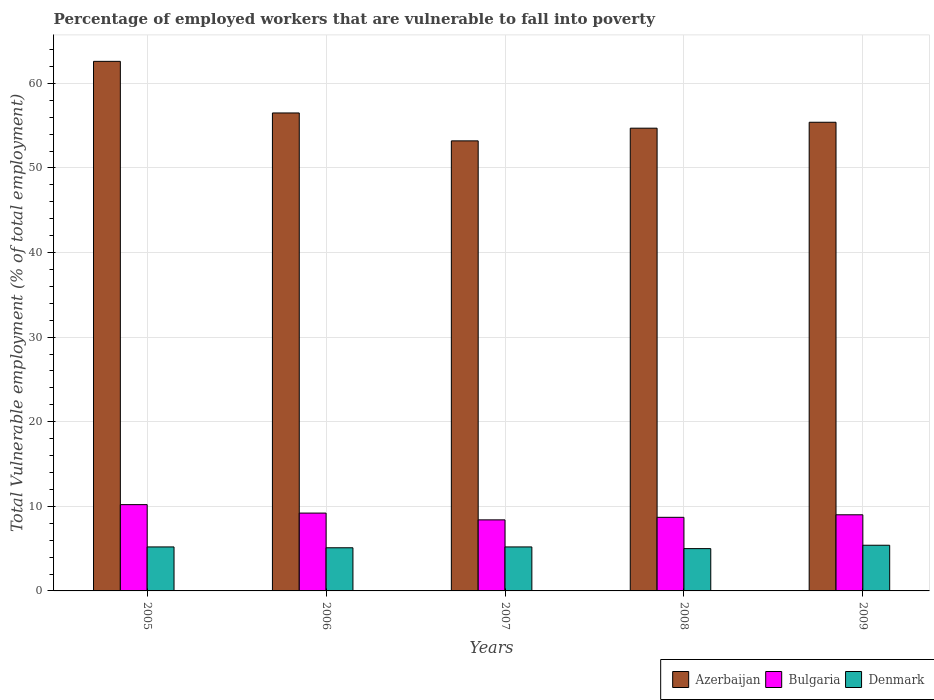How many groups of bars are there?
Offer a terse response. 5. Are the number of bars per tick equal to the number of legend labels?
Your answer should be very brief. Yes. Are the number of bars on each tick of the X-axis equal?
Give a very brief answer. Yes. How many bars are there on the 5th tick from the left?
Provide a short and direct response. 3. How many bars are there on the 1st tick from the right?
Your answer should be very brief. 3. What is the percentage of employed workers who are vulnerable to fall into poverty in Bulgaria in 2008?
Your answer should be very brief. 8.7. Across all years, what is the maximum percentage of employed workers who are vulnerable to fall into poverty in Bulgaria?
Make the answer very short. 10.2. Across all years, what is the minimum percentage of employed workers who are vulnerable to fall into poverty in Bulgaria?
Make the answer very short. 8.4. In which year was the percentage of employed workers who are vulnerable to fall into poverty in Bulgaria maximum?
Make the answer very short. 2005. In which year was the percentage of employed workers who are vulnerable to fall into poverty in Bulgaria minimum?
Give a very brief answer. 2007. What is the total percentage of employed workers who are vulnerable to fall into poverty in Denmark in the graph?
Provide a short and direct response. 25.9. What is the difference between the percentage of employed workers who are vulnerable to fall into poverty in Denmark in 2008 and that in 2009?
Make the answer very short. -0.4. What is the difference between the percentage of employed workers who are vulnerable to fall into poverty in Bulgaria in 2008 and the percentage of employed workers who are vulnerable to fall into poverty in Denmark in 2007?
Your response must be concise. 3.5. What is the average percentage of employed workers who are vulnerable to fall into poverty in Bulgaria per year?
Ensure brevity in your answer.  9.1. In the year 2009, what is the difference between the percentage of employed workers who are vulnerable to fall into poverty in Bulgaria and percentage of employed workers who are vulnerable to fall into poverty in Denmark?
Ensure brevity in your answer.  3.6. What is the ratio of the percentage of employed workers who are vulnerable to fall into poverty in Azerbaijan in 2005 to that in 2007?
Your answer should be compact. 1.18. What is the difference between the highest and the second highest percentage of employed workers who are vulnerable to fall into poverty in Bulgaria?
Provide a short and direct response. 1. What is the difference between the highest and the lowest percentage of employed workers who are vulnerable to fall into poverty in Azerbaijan?
Offer a very short reply. 9.4. In how many years, is the percentage of employed workers who are vulnerable to fall into poverty in Azerbaijan greater than the average percentage of employed workers who are vulnerable to fall into poverty in Azerbaijan taken over all years?
Your answer should be compact. 2. Is the sum of the percentage of employed workers who are vulnerable to fall into poverty in Azerbaijan in 2006 and 2009 greater than the maximum percentage of employed workers who are vulnerable to fall into poverty in Bulgaria across all years?
Keep it short and to the point. Yes. What does the 2nd bar from the left in 2008 represents?
Keep it short and to the point. Bulgaria. What does the 2nd bar from the right in 2007 represents?
Give a very brief answer. Bulgaria. Is it the case that in every year, the sum of the percentage of employed workers who are vulnerable to fall into poverty in Bulgaria and percentage of employed workers who are vulnerable to fall into poverty in Azerbaijan is greater than the percentage of employed workers who are vulnerable to fall into poverty in Denmark?
Your answer should be compact. Yes. How many bars are there?
Make the answer very short. 15. How many years are there in the graph?
Provide a succinct answer. 5. Are the values on the major ticks of Y-axis written in scientific E-notation?
Offer a very short reply. No. Does the graph contain any zero values?
Ensure brevity in your answer.  No. What is the title of the graph?
Give a very brief answer. Percentage of employed workers that are vulnerable to fall into poverty. What is the label or title of the Y-axis?
Make the answer very short. Total Vulnerable employment (% of total employment). What is the Total Vulnerable employment (% of total employment) of Azerbaijan in 2005?
Give a very brief answer. 62.6. What is the Total Vulnerable employment (% of total employment) in Bulgaria in 2005?
Your answer should be compact. 10.2. What is the Total Vulnerable employment (% of total employment) of Denmark in 2005?
Your answer should be very brief. 5.2. What is the Total Vulnerable employment (% of total employment) in Azerbaijan in 2006?
Provide a short and direct response. 56.5. What is the Total Vulnerable employment (% of total employment) of Bulgaria in 2006?
Offer a terse response. 9.2. What is the Total Vulnerable employment (% of total employment) in Denmark in 2006?
Provide a short and direct response. 5.1. What is the Total Vulnerable employment (% of total employment) of Azerbaijan in 2007?
Your answer should be compact. 53.2. What is the Total Vulnerable employment (% of total employment) of Bulgaria in 2007?
Make the answer very short. 8.4. What is the Total Vulnerable employment (% of total employment) in Denmark in 2007?
Ensure brevity in your answer.  5.2. What is the Total Vulnerable employment (% of total employment) of Azerbaijan in 2008?
Your answer should be compact. 54.7. What is the Total Vulnerable employment (% of total employment) of Bulgaria in 2008?
Ensure brevity in your answer.  8.7. What is the Total Vulnerable employment (% of total employment) in Azerbaijan in 2009?
Your answer should be very brief. 55.4. What is the Total Vulnerable employment (% of total employment) in Bulgaria in 2009?
Your response must be concise. 9. What is the Total Vulnerable employment (% of total employment) of Denmark in 2009?
Keep it short and to the point. 5.4. Across all years, what is the maximum Total Vulnerable employment (% of total employment) of Azerbaijan?
Your answer should be very brief. 62.6. Across all years, what is the maximum Total Vulnerable employment (% of total employment) in Bulgaria?
Make the answer very short. 10.2. Across all years, what is the maximum Total Vulnerable employment (% of total employment) in Denmark?
Your response must be concise. 5.4. Across all years, what is the minimum Total Vulnerable employment (% of total employment) of Azerbaijan?
Provide a succinct answer. 53.2. Across all years, what is the minimum Total Vulnerable employment (% of total employment) in Bulgaria?
Your answer should be very brief. 8.4. Across all years, what is the minimum Total Vulnerable employment (% of total employment) in Denmark?
Give a very brief answer. 5. What is the total Total Vulnerable employment (% of total employment) of Azerbaijan in the graph?
Your answer should be compact. 282.4. What is the total Total Vulnerable employment (% of total employment) in Bulgaria in the graph?
Ensure brevity in your answer.  45.5. What is the total Total Vulnerable employment (% of total employment) of Denmark in the graph?
Your response must be concise. 25.9. What is the difference between the Total Vulnerable employment (% of total employment) of Bulgaria in 2005 and that in 2006?
Provide a succinct answer. 1. What is the difference between the Total Vulnerable employment (% of total employment) in Azerbaijan in 2005 and that in 2007?
Offer a terse response. 9.4. What is the difference between the Total Vulnerable employment (% of total employment) of Denmark in 2005 and that in 2007?
Make the answer very short. 0. What is the difference between the Total Vulnerable employment (% of total employment) of Azerbaijan in 2005 and that in 2008?
Your answer should be compact. 7.9. What is the difference between the Total Vulnerable employment (% of total employment) of Bulgaria in 2005 and that in 2008?
Provide a succinct answer. 1.5. What is the difference between the Total Vulnerable employment (% of total employment) in Denmark in 2005 and that in 2008?
Offer a very short reply. 0.2. What is the difference between the Total Vulnerable employment (% of total employment) in Azerbaijan in 2005 and that in 2009?
Keep it short and to the point. 7.2. What is the difference between the Total Vulnerable employment (% of total employment) in Azerbaijan in 2006 and that in 2007?
Your answer should be very brief. 3.3. What is the difference between the Total Vulnerable employment (% of total employment) in Bulgaria in 2006 and that in 2007?
Make the answer very short. 0.8. What is the difference between the Total Vulnerable employment (% of total employment) of Azerbaijan in 2006 and that in 2008?
Ensure brevity in your answer.  1.8. What is the difference between the Total Vulnerable employment (% of total employment) of Bulgaria in 2006 and that in 2008?
Make the answer very short. 0.5. What is the difference between the Total Vulnerable employment (% of total employment) of Azerbaijan in 2006 and that in 2009?
Your response must be concise. 1.1. What is the difference between the Total Vulnerable employment (% of total employment) of Azerbaijan in 2007 and that in 2009?
Keep it short and to the point. -2.2. What is the difference between the Total Vulnerable employment (% of total employment) in Denmark in 2007 and that in 2009?
Your response must be concise. -0.2. What is the difference between the Total Vulnerable employment (% of total employment) of Azerbaijan in 2008 and that in 2009?
Your answer should be very brief. -0.7. What is the difference between the Total Vulnerable employment (% of total employment) of Azerbaijan in 2005 and the Total Vulnerable employment (% of total employment) of Bulgaria in 2006?
Keep it short and to the point. 53.4. What is the difference between the Total Vulnerable employment (% of total employment) of Azerbaijan in 2005 and the Total Vulnerable employment (% of total employment) of Denmark in 2006?
Provide a short and direct response. 57.5. What is the difference between the Total Vulnerable employment (% of total employment) of Azerbaijan in 2005 and the Total Vulnerable employment (% of total employment) of Bulgaria in 2007?
Offer a very short reply. 54.2. What is the difference between the Total Vulnerable employment (% of total employment) in Azerbaijan in 2005 and the Total Vulnerable employment (% of total employment) in Denmark in 2007?
Your response must be concise. 57.4. What is the difference between the Total Vulnerable employment (% of total employment) in Bulgaria in 2005 and the Total Vulnerable employment (% of total employment) in Denmark in 2007?
Offer a terse response. 5. What is the difference between the Total Vulnerable employment (% of total employment) in Azerbaijan in 2005 and the Total Vulnerable employment (% of total employment) in Bulgaria in 2008?
Make the answer very short. 53.9. What is the difference between the Total Vulnerable employment (% of total employment) of Azerbaijan in 2005 and the Total Vulnerable employment (% of total employment) of Denmark in 2008?
Make the answer very short. 57.6. What is the difference between the Total Vulnerable employment (% of total employment) of Azerbaijan in 2005 and the Total Vulnerable employment (% of total employment) of Bulgaria in 2009?
Offer a terse response. 53.6. What is the difference between the Total Vulnerable employment (% of total employment) in Azerbaijan in 2005 and the Total Vulnerable employment (% of total employment) in Denmark in 2009?
Offer a very short reply. 57.2. What is the difference between the Total Vulnerable employment (% of total employment) in Azerbaijan in 2006 and the Total Vulnerable employment (% of total employment) in Bulgaria in 2007?
Offer a terse response. 48.1. What is the difference between the Total Vulnerable employment (% of total employment) of Azerbaijan in 2006 and the Total Vulnerable employment (% of total employment) of Denmark in 2007?
Make the answer very short. 51.3. What is the difference between the Total Vulnerable employment (% of total employment) in Azerbaijan in 2006 and the Total Vulnerable employment (% of total employment) in Bulgaria in 2008?
Your answer should be very brief. 47.8. What is the difference between the Total Vulnerable employment (% of total employment) in Azerbaijan in 2006 and the Total Vulnerable employment (% of total employment) in Denmark in 2008?
Provide a succinct answer. 51.5. What is the difference between the Total Vulnerable employment (% of total employment) in Azerbaijan in 2006 and the Total Vulnerable employment (% of total employment) in Bulgaria in 2009?
Your answer should be very brief. 47.5. What is the difference between the Total Vulnerable employment (% of total employment) in Azerbaijan in 2006 and the Total Vulnerable employment (% of total employment) in Denmark in 2009?
Provide a short and direct response. 51.1. What is the difference between the Total Vulnerable employment (% of total employment) of Azerbaijan in 2007 and the Total Vulnerable employment (% of total employment) of Bulgaria in 2008?
Your answer should be very brief. 44.5. What is the difference between the Total Vulnerable employment (% of total employment) in Azerbaijan in 2007 and the Total Vulnerable employment (% of total employment) in Denmark in 2008?
Offer a very short reply. 48.2. What is the difference between the Total Vulnerable employment (% of total employment) in Bulgaria in 2007 and the Total Vulnerable employment (% of total employment) in Denmark in 2008?
Your answer should be very brief. 3.4. What is the difference between the Total Vulnerable employment (% of total employment) of Azerbaijan in 2007 and the Total Vulnerable employment (% of total employment) of Bulgaria in 2009?
Provide a succinct answer. 44.2. What is the difference between the Total Vulnerable employment (% of total employment) in Azerbaijan in 2007 and the Total Vulnerable employment (% of total employment) in Denmark in 2009?
Provide a succinct answer. 47.8. What is the difference between the Total Vulnerable employment (% of total employment) of Azerbaijan in 2008 and the Total Vulnerable employment (% of total employment) of Bulgaria in 2009?
Provide a short and direct response. 45.7. What is the difference between the Total Vulnerable employment (% of total employment) in Azerbaijan in 2008 and the Total Vulnerable employment (% of total employment) in Denmark in 2009?
Offer a terse response. 49.3. What is the difference between the Total Vulnerable employment (% of total employment) in Bulgaria in 2008 and the Total Vulnerable employment (% of total employment) in Denmark in 2009?
Ensure brevity in your answer.  3.3. What is the average Total Vulnerable employment (% of total employment) of Azerbaijan per year?
Your response must be concise. 56.48. What is the average Total Vulnerable employment (% of total employment) in Bulgaria per year?
Make the answer very short. 9.1. What is the average Total Vulnerable employment (% of total employment) of Denmark per year?
Provide a short and direct response. 5.18. In the year 2005, what is the difference between the Total Vulnerable employment (% of total employment) of Azerbaijan and Total Vulnerable employment (% of total employment) of Bulgaria?
Provide a succinct answer. 52.4. In the year 2005, what is the difference between the Total Vulnerable employment (% of total employment) in Azerbaijan and Total Vulnerable employment (% of total employment) in Denmark?
Provide a short and direct response. 57.4. In the year 2006, what is the difference between the Total Vulnerable employment (% of total employment) in Azerbaijan and Total Vulnerable employment (% of total employment) in Bulgaria?
Offer a very short reply. 47.3. In the year 2006, what is the difference between the Total Vulnerable employment (% of total employment) of Azerbaijan and Total Vulnerable employment (% of total employment) of Denmark?
Offer a very short reply. 51.4. In the year 2006, what is the difference between the Total Vulnerable employment (% of total employment) in Bulgaria and Total Vulnerable employment (% of total employment) in Denmark?
Provide a succinct answer. 4.1. In the year 2007, what is the difference between the Total Vulnerable employment (% of total employment) of Azerbaijan and Total Vulnerable employment (% of total employment) of Bulgaria?
Your answer should be compact. 44.8. In the year 2008, what is the difference between the Total Vulnerable employment (% of total employment) in Azerbaijan and Total Vulnerable employment (% of total employment) in Denmark?
Your answer should be compact. 49.7. In the year 2008, what is the difference between the Total Vulnerable employment (% of total employment) in Bulgaria and Total Vulnerable employment (% of total employment) in Denmark?
Keep it short and to the point. 3.7. In the year 2009, what is the difference between the Total Vulnerable employment (% of total employment) of Azerbaijan and Total Vulnerable employment (% of total employment) of Bulgaria?
Your response must be concise. 46.4. In the year 2009, what is the difference between the Total Vulnerable employment (% of total employment) in Bulgaria and Total Vulnerable employment (% of total employment) in Denmark?
Make the answer very short. 3.6. What is the ratio of the Total Vulnerable employment (% of total employment) in Azerbaijan in 2005 to that in 2006?
Your answer should be compact. 1.11. What is the ratio of the Total Vulnerable employment (% of total employment) in Bulgaria in 2005 to that in 2006?
Make the answer very short. 1.11. What is the ratio of the Total Vulnerable employment (% of total employment) in Denmark in 2005 to that in 2006?
Ensure brevity in your answer.  1.02. What is the ratio of the Total Vulnerable employment (% of total employment) in Azerbaijan in 2005 to that in 2007?
Give a very brief answer. 1.18. What is the ratio of the Total Vulnerable employment (% of total employment) of Bulgaria in 2005 to that in 2007?
Ensure brevity in your answer.  1.21. What is the ratio of the Total Vulnerable employment (% of total employment) in Denmark in 2005 to that in 2007?
Provide a succinct answer. 1. What is the ratio of the Total Vulnerable employment (% of total employment) in Azerbaijan in 2005 to that in 2008?
Give a very brief answer. 1.14. What is the ratio of the Total Vulnerable employment (% of total employment) in Bulgaria in 2005 to that in 2008?
Offer a terse response. 1.17. What is the ratio of the Total Vulnerable employment (% of total employment) in Denmark in 2005 to that in 2008?
Give a very brief answer. 1.04. What is the ratio of the Total Vulnerable employment (% of total employment) of Azerbaijan in 2005 to that in 2009?
Provide a succinct answer. 1.13. What is the ratio of the Total Vulnerable employment (% of total employment) in Bulgaria in 2005 to that in 2009?
Provide a short and direct response. 1.13. What is the ratio of the Total Vulnerable employment (% of total employment) in Azerbaijan in 2006 to that in 2007?
Offer a terse response. 1.06. What is the ratio of the Total Vulnerable employment (% of total employment) in Bulgaria in 2006 to that in 2007?
Provide a succinct answer. 1.1. What is the ratio of the Total Vulnerable employment (% of total employment) of Denmark in 2006 to that in 2007?
Give a very brief answer. 0.98. What is the ratio of the Total Vulnerable employment (% of total employment) of Azerbaijan in 2006 to that in 2008?
Offer a very short reply. 1.03. What is the ratio of the Total Vulnerable employment (% of total employment) in Bulgaria in 2006 to that in 2008?
Ensure brevity in your answer.  1.06. What is the ratio of the Total Vulnerable employment (% of total employment) in Denmark in 2006 to that in 2008?
Provide a succinct answer. 1.02. What is the ratio of the Total Vulnerable employment (% of total employment) of Azerbaijan in 2006 to that in 2009?
Make the answer very short. 1.02. What is the ratio of the Total Vulnerable employment (% of total employment) of Bulgaria in 2006 to that in 2009?
Make the answer very short. 1.02. What is the ratio of the Total Vulnerable employment (% of total employment) in Denmark in 2006 to that in 2009?
Give a very brief answer. 0.94. What is the ratio of the Total Vulnerable employment (% of total employment) of Azerbaijan in 2007 to that in 2008?
Offer a very short reply. 0.97. What is the ratio of the Total Vulnerable employment (% of total employment) of Bulgaria in 2007 to that in 2008?
Offer a very short reply. 0.97. What is the ratio of the Total Vulnerable employment (% of total employment) of Denmark in 2007 to that in 2008?
Make the answer very short. 1.04. What is the ratio of the Total Vulnerable employment (% of total employment) in Azerbaijan in 2007 to that in 2009?
Keep it short and to the point. 0.96. What is the ratio of the Total Vulnerable employment (% of total employment) of Denmark in 2007 to that in 2009?
Your response must be concise. 0.96. What is the ratio of the Total Vulnerable employment (% of total employment) in Azerbaijan in 2008 to that in 2009?
Provide a short and direct response. 0.99. What is the ratio of the Total Vulnerable employment (% of total employment) of Bulgaria in 2008 to that in 2009?
Keep it short and to the point. 0.97. What is the ratio of the Total Vulnerable employment (% of total employment) in Denmark in 2008 to that in 2009?
Your response must be concise. 0.93. What is the difference between the highest and the second highest Total Vulnerable employment (% of total employment) of Bulgaria?
Provide a succinct answer. 1. What is the difference between the highest and the second highest Total Vulnerable employment (% of total employment) in Denmark?
Keep it short and to the point. 0.2. 